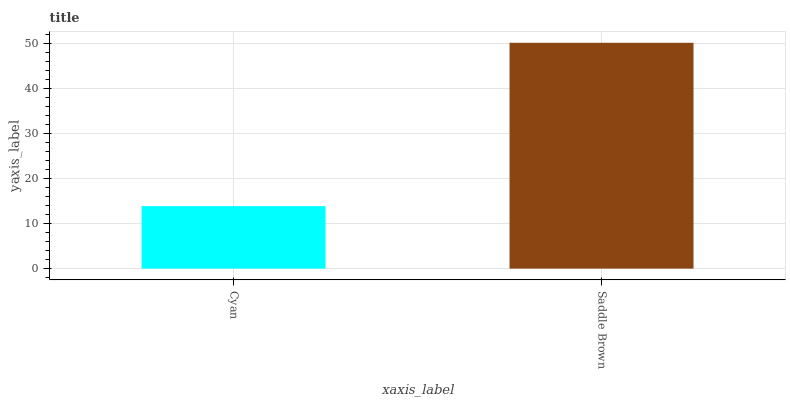Is Cyan the minimum?
Answer yes or no. Yes. Is Saddle Brown the maximum?
Answer yes or no. Yes. Is Saddle Brown the minimum?
Answer yes or no. No. Is Saddle Brown greater than Cyan?
Answer yes or no. Yes. Is Cyan less than Saddle Brown?
Answer yes or no. Yes. Is Cyan greater than Saddle Brown?
Answer yes or no. No. Is Saddle Brown less than Cyan?
Answer yes or no. No. Is Saddle Brown the high median?
Answer yes or no. Yes. Is Cyan the low median?
Answer yes or no. Yes. Is Cyan the high median?
Answer yes or no. No. Is Saddle Brown the low median?
Answer yes or no. No. 